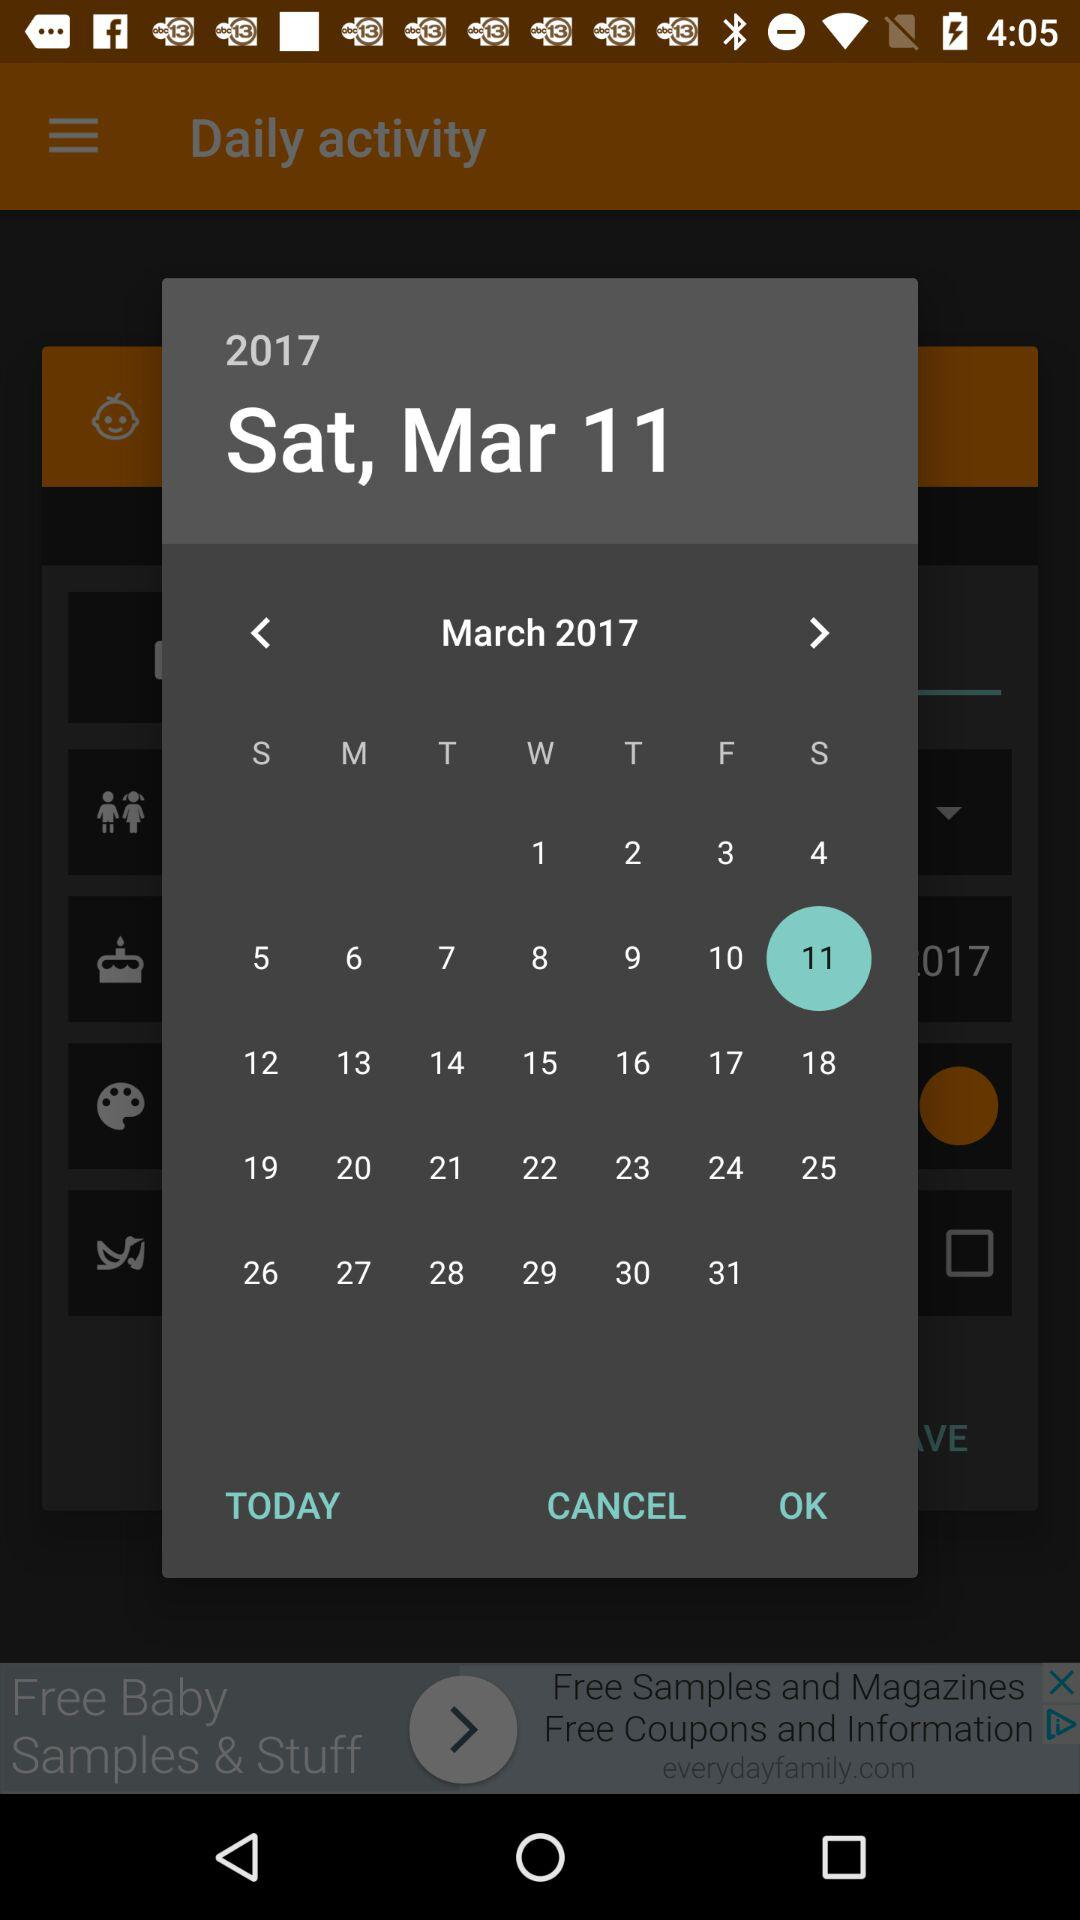What is the selected date? The selected date is Saturday, March 11, 2017. 